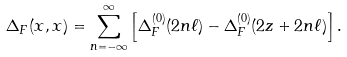Convert formula to latex. <formula><loc_0><loc_0><loc_500><loc_500>\Delta _ { F } ( x , x ) = \sum _ { n = - \infty } ^ { \infty } \left [ \Delta _ { F } ^ { ( 0 ) } ( 2 n \ell ) - \Delta _ { F } ^ { ( 0 ) } ( 2 z + 2 n \ell ) \right ] .</formula> 